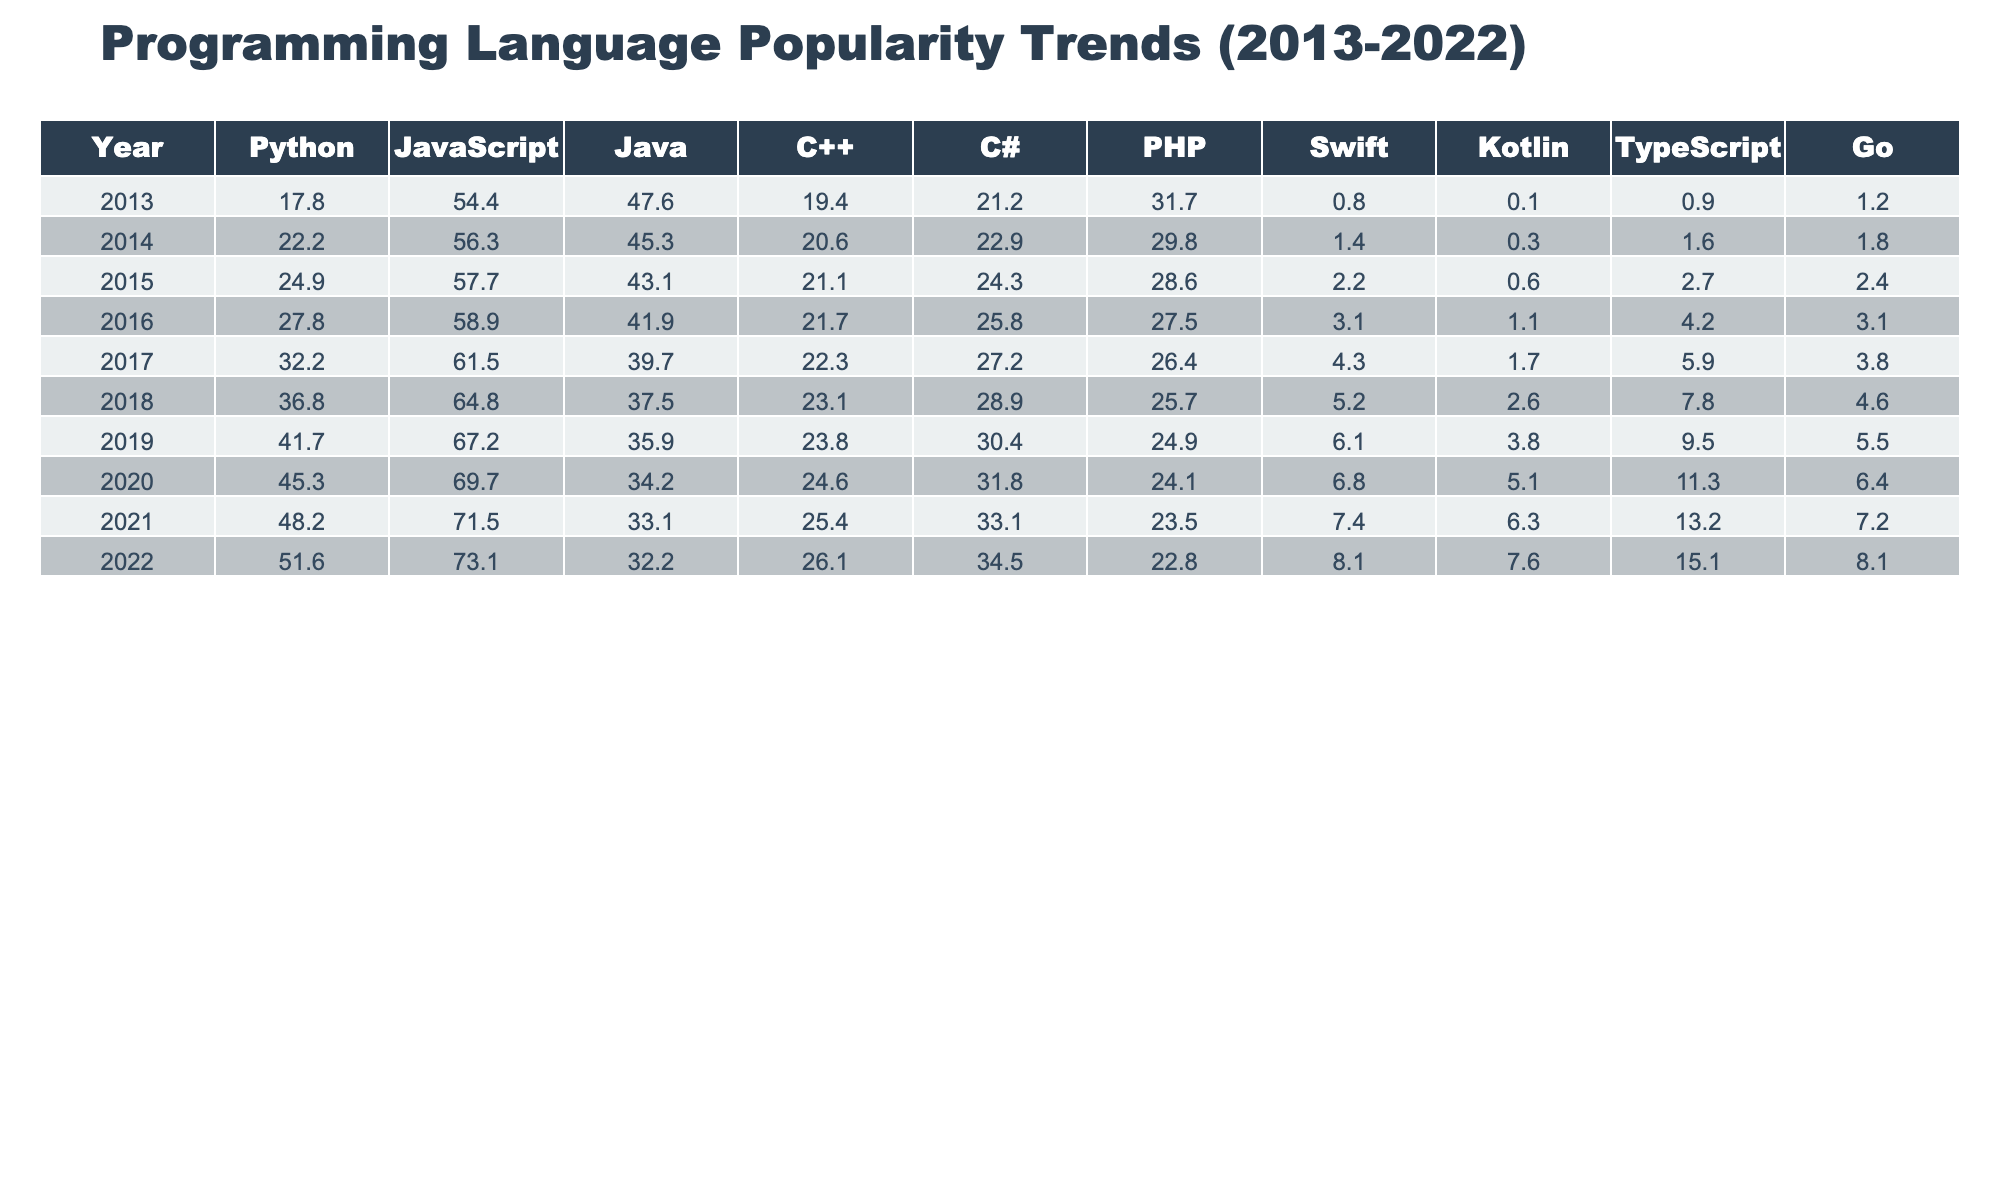What was the popularity percentage of Python in 2020? In the table, find the row for the year 2020, then look under the Python column to see its value, which is 45.3.
Answer: 45.3 Which programming language had the highest popularity in 2018? By checking the 2018 row, JavaScript has the highest value at 64.8, compared to the others.
Answer: JavaScript What is the difference in popularity percentage between C# in 2015 and C# in 2022? Look at the C# column for 2015, which is 24.3, and for 2022, which is 34.5. The difference is 34.5 - 24.3 = 10.2.
Answer: 10.2 What was the average popularity percentage of Java between 2013 and 2022? Sum the Java values from the years 2013 (47.6), 2014 (45.3), 2015 (43.1), 2016 (41.9), 2017 (39.7), 2018 (37.5), 2019 (35.9), 2020 (34.2), 2021 (33.1), and 2022 (32.2), which totals 419.5. Divide this by 10 years to get an average of 41.95.
Answer: 41.95 Is it true that Go's popularity has consistently increased every year from 2013 to 2022? Checking the Go values yearly, they are 1.2, 1.8, 2.4, 3.1, 3.8, 4.6, 5.5, 6.4, 7.2, and 8.1. All values show an increase, confirming that it has consistently risen.
Answer: Yes What is the total popularity percentage of all languages in 2022? To find the total, sum the values of all programming languages in 2022: Python (51.6), JavaScript (73.1), Java (32.2), C++ (26.1), C# (34.5), PHP (22.8), Swift (8.1), Kotlin (7.6), TypeScript (15.1), and Go (8.1), which totals 279.1.
Answer: 279.1 Which language shows the smallest increase in popularity from 2013 to 2022? Compare the increase from 2013 to 2022 across all languages. For C++, the values go from 19.4 to 26.1, an increase of 6.7. For others, the increases are larger, indicating C++ has the smallest increase.
Answer: C++ In which year did Swift first register a popularity percentage higher than 5%? Looking specifically at the Swift column, values are 0.8, 1.4, 2.2, 3.1, 4.3, 5.2, so 2018 is the first year it surpassed 5%.
Answer: 2018 What is the trend for PHP from 2013 to 2022? Looking at the PHP values: 31.7, 29.8, 28.6, 27.5, 26.4, 25.7, 24.9, 24.1, 22.8, the trend shows a general decline in popularity over the years.
Answer: Declining 